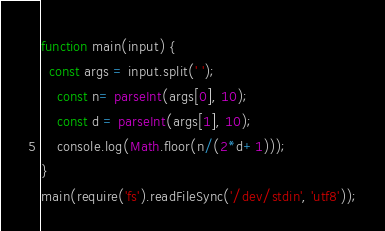Convert code to text. <code><loc_0><loc_0><loc_500><loc_500><_JavaScript_>function main(input) {
  const args = input.split(' ');
    const n= parseInt(args[0], 10);
    const d = parseInt(args[1], 10);
    console.log(Math.floor(n/(2*d+1)));
}
main(require('fs').readFileSync('/dev/stdin', 'utf8'));</code> 